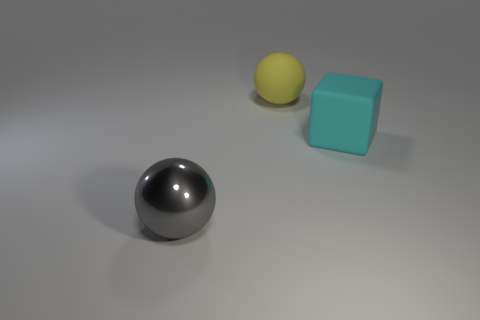What lighting conditions are implied in the scene? The image suggests an indoor setting with soft, diffused lighting, as evidenced by the gentle shadows under the objects and the lack of harsh contrasts or bright highlights. 